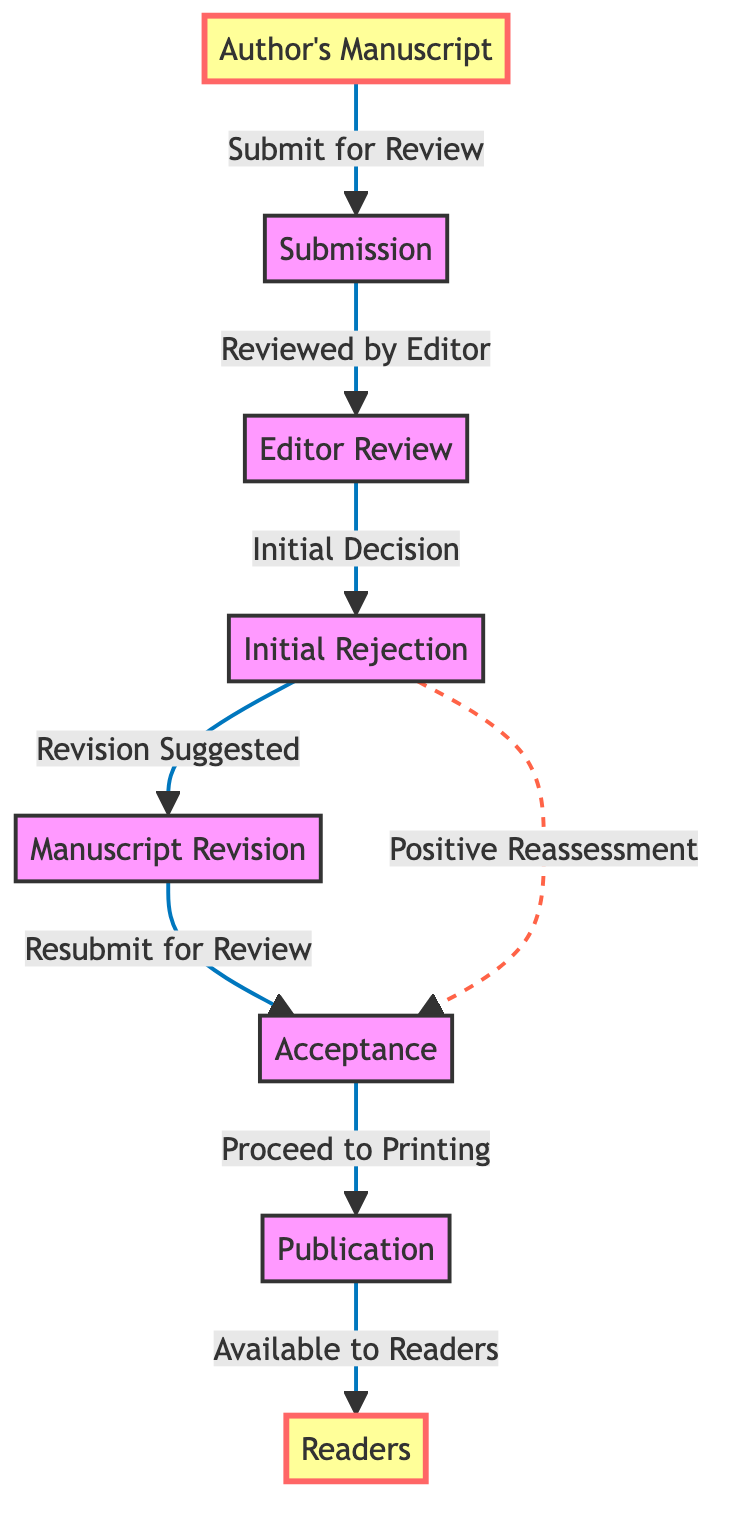What is the first step in the manuscript's journey? The diagram indicates that the manuscript's journey begins with the "Author's Manuscript," which is represented as the first node in the flow.
Answer: Author's Manuscript What node comes after submission? Following the "Submission" node in the diagram, the next node is "Editor Review." Thus, the direct sequence identifies "Editor Review" as the next step.
Answer: Editor Review How many edges are drawn from the "Editor Review" node? Counting the outgoing edges from the "Editor Review" node, there are two edges: one leading to "Initial Rejection" and the other forming a dashed line back to "Acceptance." Therefore, there are two outgoing edges.
Answer: Two What happens after "Initial Rejection"? According to the diagram, after "Initial Rejection," the next process is "Revision Suggested" indicated by the arrow leading from "Initial Rejection" to "Manuscript Revision."
Answer: Revision Suggested What is the final stage before a manuscript is available to readers? Before the manuscript reaches the "Readers," the last step is "Publication," which is directly before "Readers" in the flow. Thus, "Publication" is the final stage prior to availability to readers.
Answer: Publication How many total nodes are represented in the diagram? The entire diagram displays a total of seven distinct nodes if we count "Author's Manuscript," "Submission," "Editor Review," "Initial Rejection," "Manuscript Revision," "Acceptance," "Publication," and "Readers." Therefore, there are seven nodes.
Answer: Seven What does the dashed line from "Initial Rejection" indicate? The dashed line from "Initial Rejection" to "Acceptance" signifies a relationship that is different from standard progression—specifically a "Positive Reassessment" that can occur upon re-evaluation of a previously rejected manuscript.
Answer: Positive Reassessment Which step follows "Manuscript Revision"? The flow reveals that after the "Manuscript Revision" phase, the next step is "Accepting," thus connecting to the next stage in the publication process.
Answer: Acceptance 